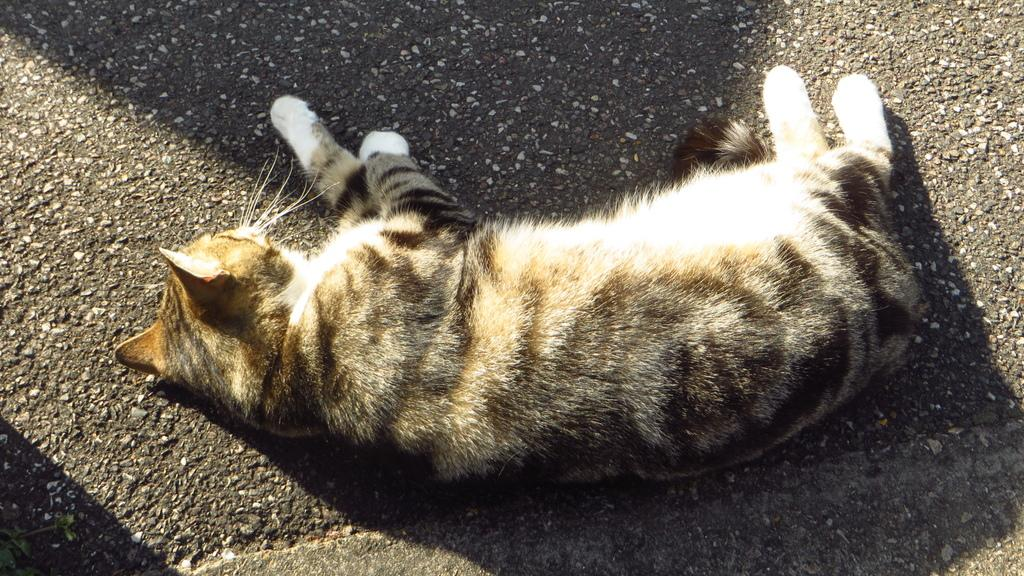What animal is present in the image? There is a cat in the image. Where is the cat located in the image? The cat is lying on the road. Is the cat attacking a river in the image? There is no river present in the image, and the cat is not attacking anything. 